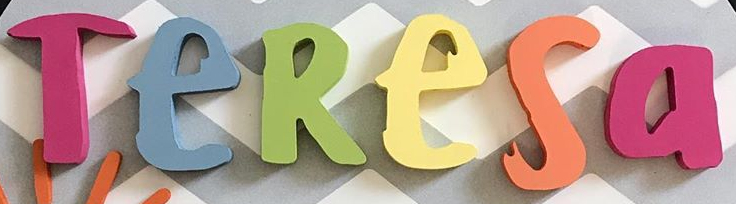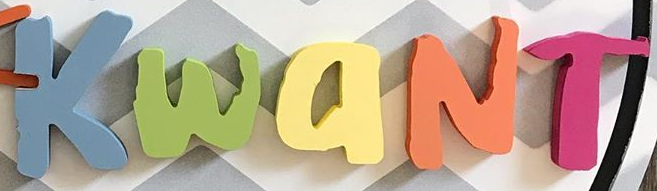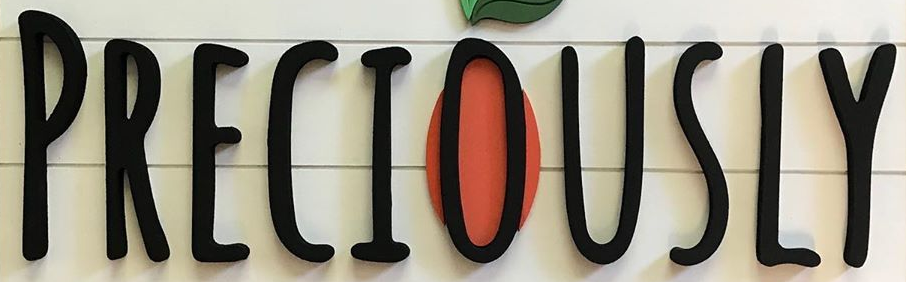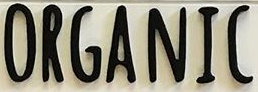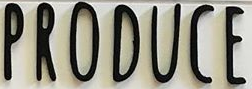Read the text from these images in sequence, separated by a semicolon. TeResa; KwaNT; PRECIOUSLY; ORGANIC; PRODUCE 